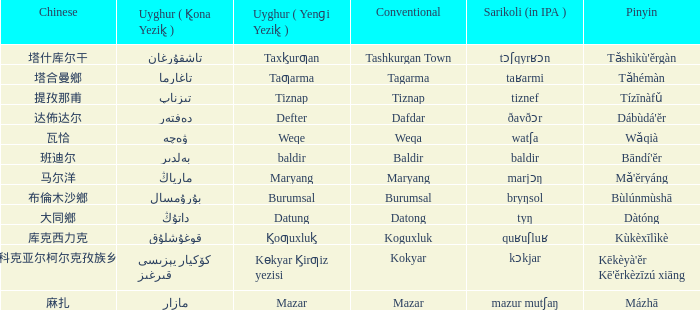Name the uyghur for  瓦恰 ۋەچە. 